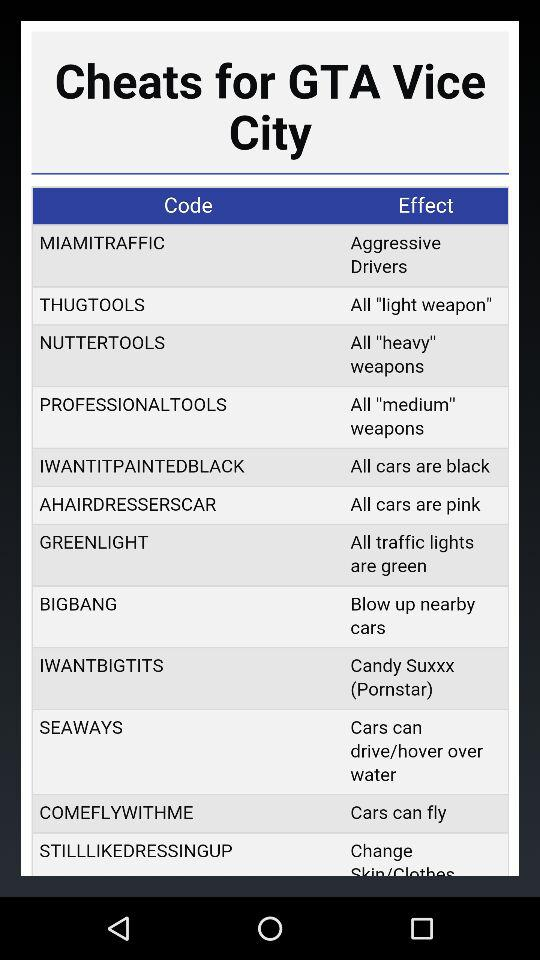What is the Miami traffic code?
When the provided information is insufficient, respond with <no answer>. <no answer> 